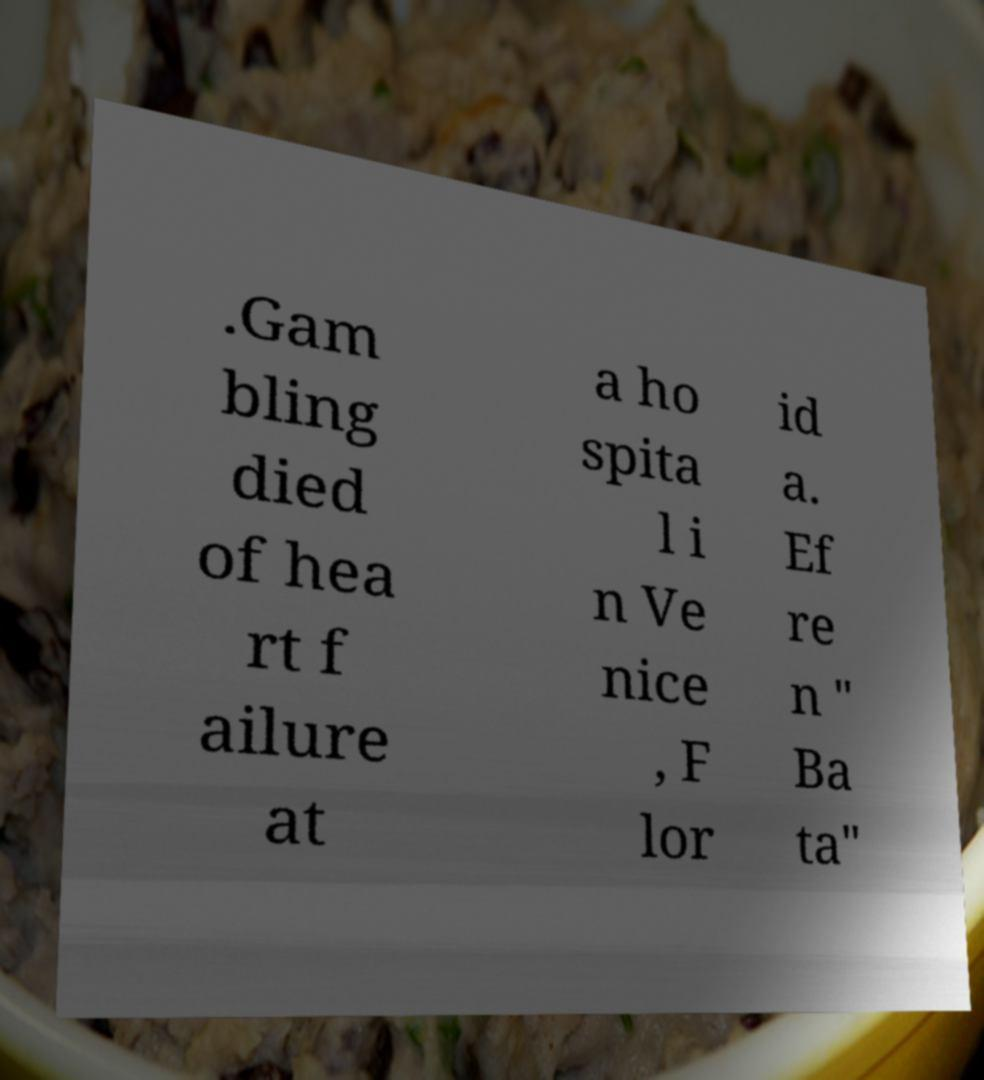What messages or text are displayed in this image? I need them in a readable, typed format. .Gam bling died of hea rt f ailure at a ho spita l i n Ve nice , F lor id a. Ef re n " Ba ta" 